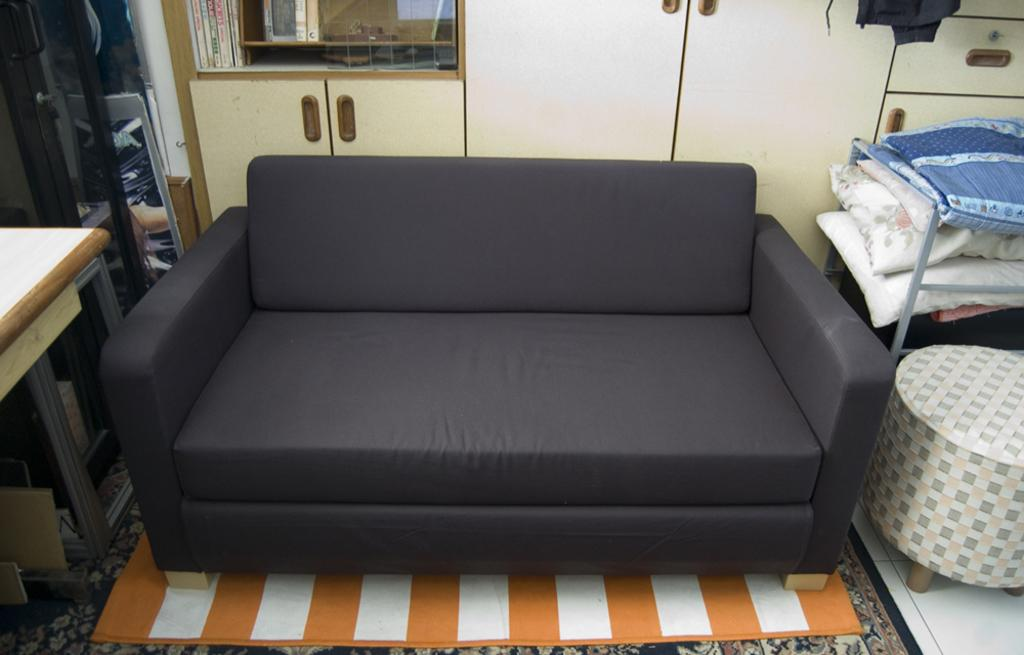What type of furniture is in the image? There is a sofa in the image. What is the surface on which the furniture is placed? The image contains a floor. What other piece of furniture is present in the image? There is a table in the image. Are there any additional items on the sofa? Yes, there are pillows in the image. What can be seen in the background of the image? There is a cupboard visible in the background of the image. What type of skirt is draped over the sofa in the image? There is no skirt present in the image; it features a sofa, table, pillows, and a cupboard. 